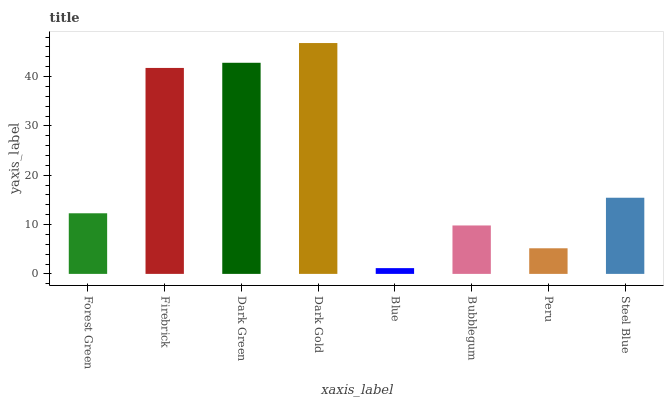Is Blue the minimum?
Answer yes or no. Yes. Is Dark Gold the maximum?
Answer yes or no. Yes. Is Firebrick the minimum?
Answer yes or no. No. Is Firebrick the maximum?
Answer yes or no. No. Is Firebrick greater than Forest Green?
Answer yes or no. Yes. Is Forest Green less than Firebrick?
Answer yes or no. Yes. Is Forest Green greater than Firebrick?
Answer yes or no. No. Is Firebrick less than Forest Green?
Answer yes or no. No. Is Steel Blue the high median?
Answer yes or no. Yes. Is Forest Green the low median?
Answer yes or no. Yes. Is Dark Gold the high median?
Answer yes or no. No. Is Dark Gold the low median?
Answer yes or no. No. 